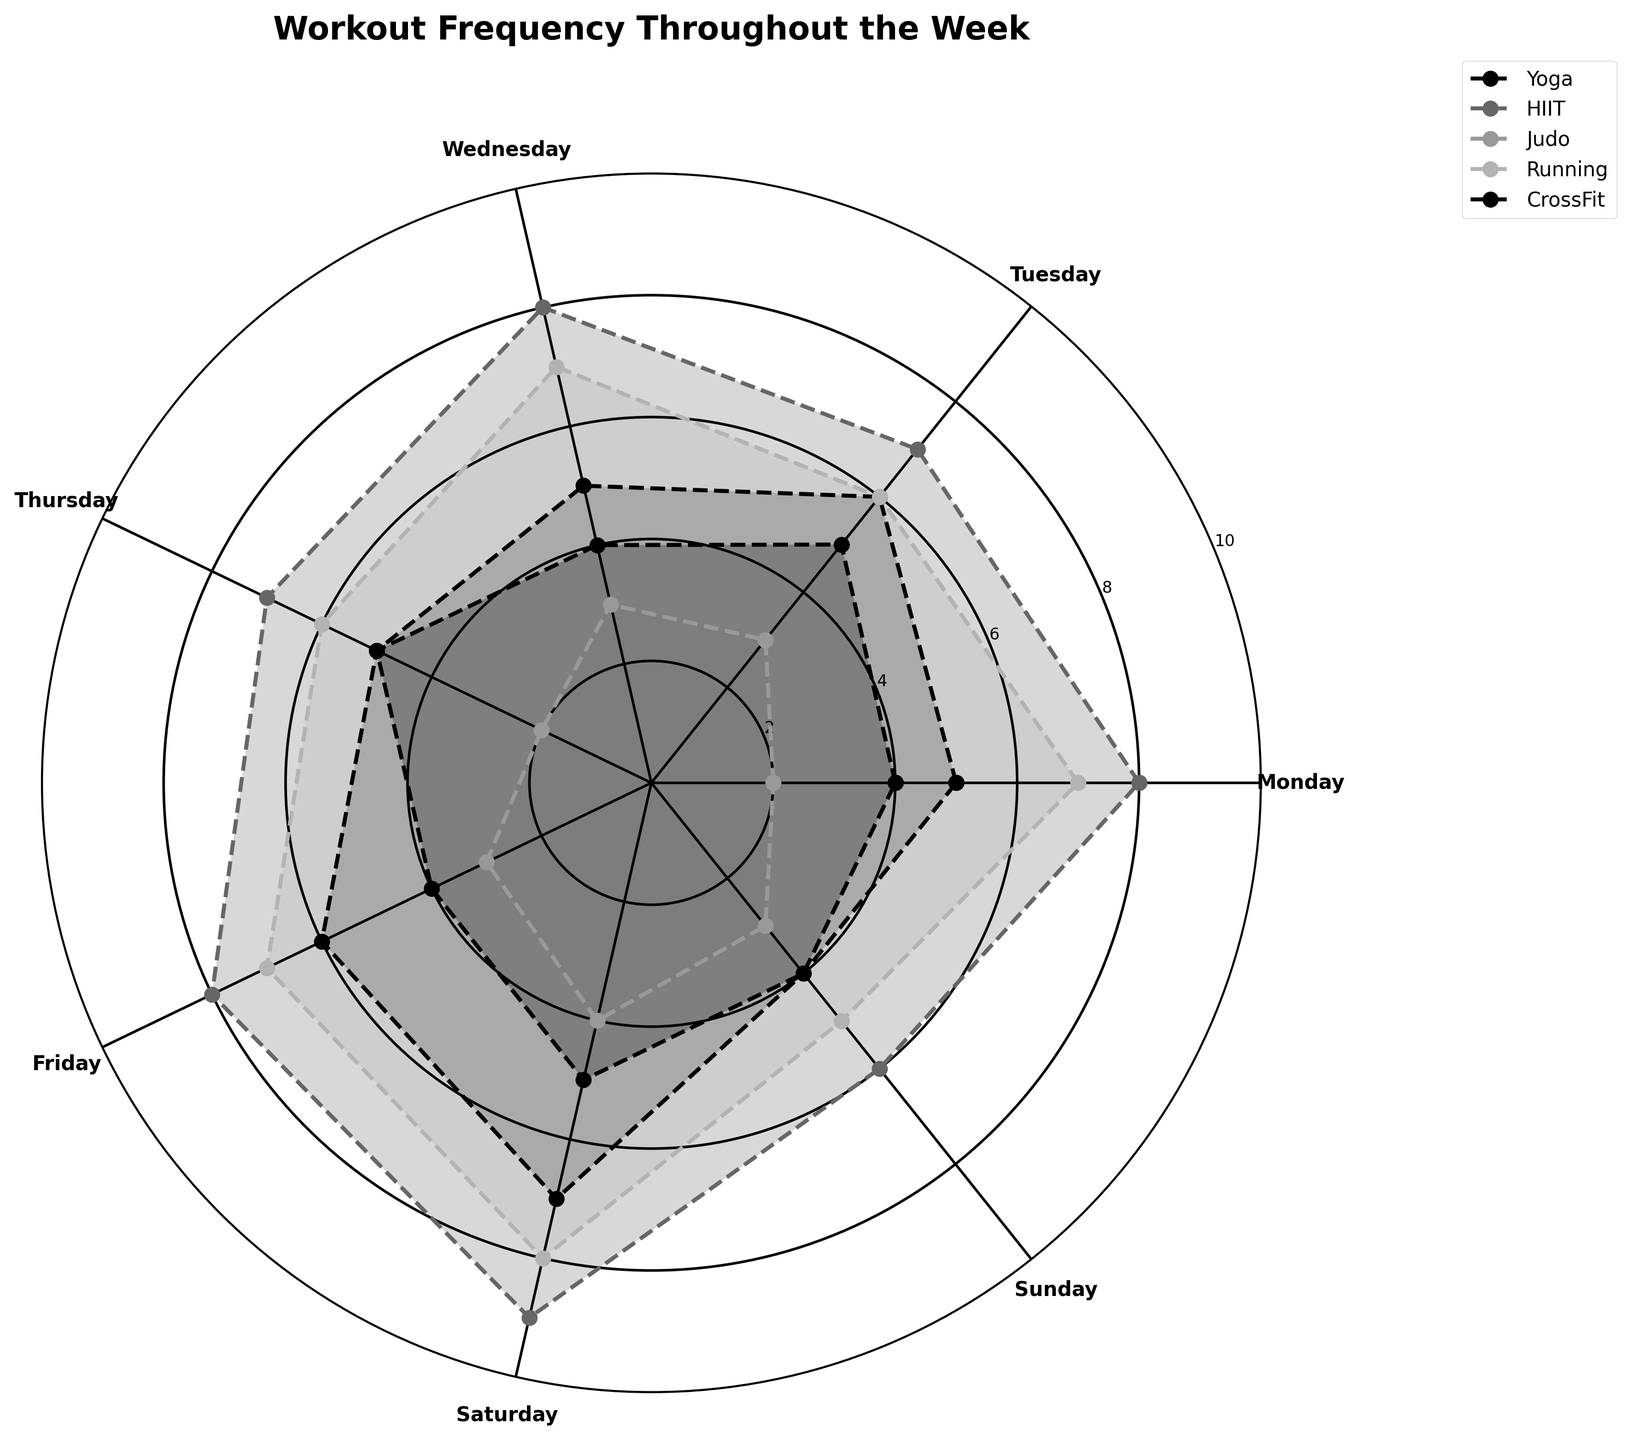What is the title of the figure? The title of the figure can be found at the top of the plot, usually in a larger and bold font. It provides the main focus or topic of the chart.
Answer: Workout Frequency Throughout the Week How many different types of workouts are shown in the figure? The number of workout types can be identified by the different lines and labels in the legend.
Answer: 5 Which workout type has the highest frequency on Saturday? Look at the lines on the rose chart for Saturday and compare the frequencies. The highest point will correspond to the workout with the highest frequency.
Answer: HIIT What is the average frequency of Yoga throughout the week? Calculate the average by summing the frequencies for Yoga on each day and then dividing by the number of days.
Answer: (5 + 6 + 5 + 5 + 6 + 7 + 4) / 7 = 38 / 7 ≈ 5.43 On which day does CrossFit have the lowest frequency? Identify the day where the line for CrossFit has the smallest value.
Answer: Monday/Thursday/Sunday (tied) By how much does the frequency of Running on Sunday differ from Wednesday? Find the frequencies of Running on Sunday and Wednesday, then subtract the smaller number from the larger one.
Answer: 7 - 5 = 2 Which workout type shows the most consistent frequency throughout the week? Compare the variations in the frequencies (peaks and troughs) of all workout types by looking at the lines on the rose chart. The most consistent will have the least variation.
Answer: Yoga Compare the frequency of Judo on Monday to Saturday. Identify the frequencies of Judo on both days and compare them to see which one is greater or if they are equal.
Answer: Saturday is higher with a frequency of 4 compared to Monday's 2 What is the second most popular workout on Tuesday? Look at the frequencies for all workout types on Tuesday and identify the second highest frequency.
Answer: Running and Yoga (both tied with a frequency of 6) What is the total frequency of HIIT over the weekend (Saturday and Sunday)? Sum the frequencies of HIIT on Saturday and Sunday.
Answer: 9 + 6 = 15 